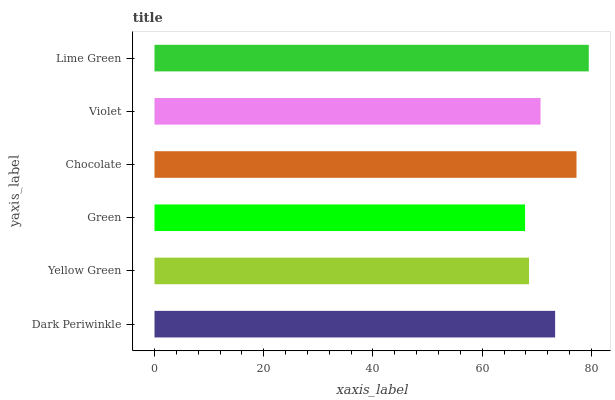Is Green the minimum?
Answer yes or no. Yes. Is Lime Green the maximum?
Answer yes or no. Yes. Is Yellow Green the minimum?
Answer yes or no. No. Is Yellow Green the maximum?
Answer yes or no. No. Is Dark Periwinkle greater than Yellow Green?
Answer yes or no. Yes. Is Yellow Green less than Dark Periwinkle?
Answer yes or no. Yes. Is Yellow Green greater than Dark Periwinkle?
Answer yes or no. No. Is Dark Periwinkle less than Yellow Green?
Answer yes or no. No. Is Dark Periwinkle the high median?
Answer yes or no. Yes. Is Violet the low median?
Answer yes or no. Yes. Is Green the high median?
Answer yes or no. No. Is Dark Periwinkle the low median?
Answer yes or no. No. 